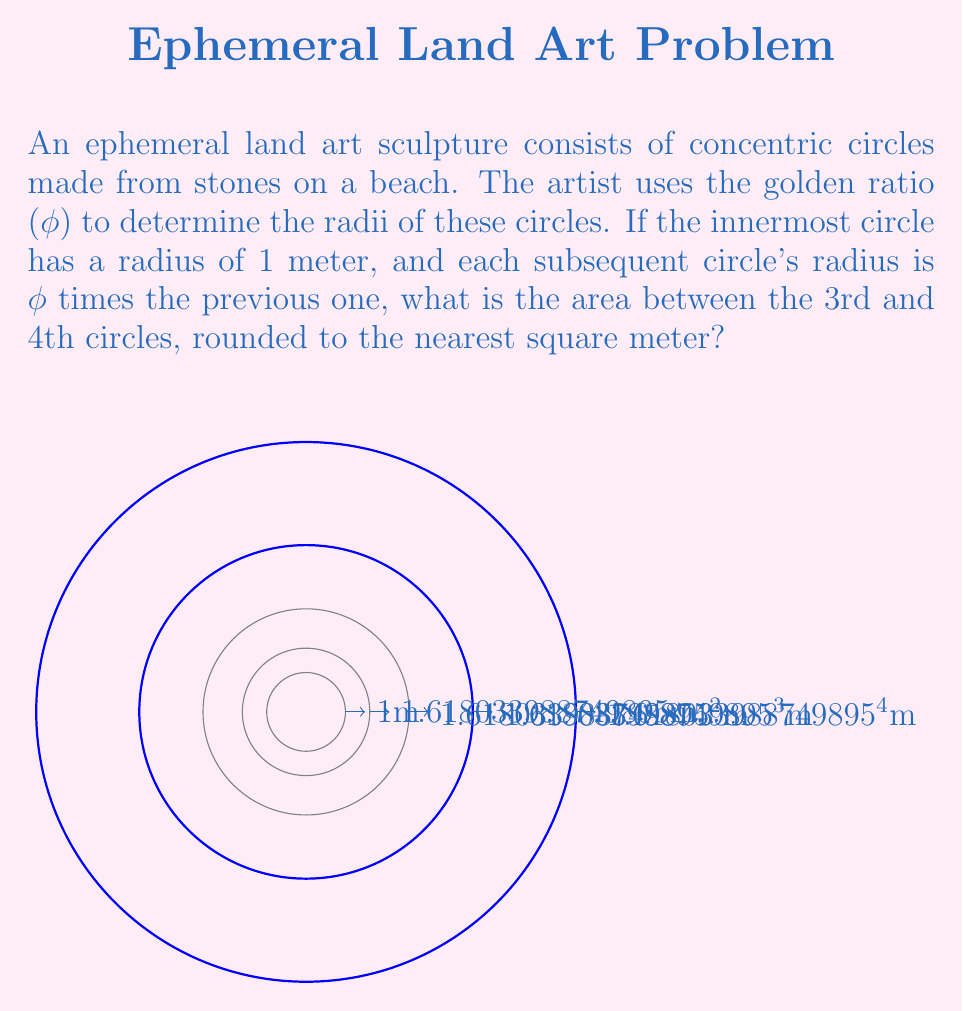Can you solve this math problem? Let's approach this step-by-step:

1) First, recall that the golden ratio φ ≈ 1.618034...

2) The radii of the circles are:
   1st circle: $r_1 = 1$ m
   2nd circle: $r_2 = φ$ m
   3rd circle: $r_3 = φ^2$ m
   4th circle: $r_4 = φ^3$ m

3) The area between the 3rd and 4th circles is the difference of their areas:
   $A = π(r_4^2 - r_3^2)$

4) Substituting the radii:
   $A = π((φ^3)^2 - (φ^2)^2)$

5) Simplify:
   $A = π(φ^6 - φ^4)$

6) Factor out φ^4:
   $A = πφ^4(φ^2 - 1)$

7) Recall the identity $φ^2 = φ + 1$:
   $A = πφ^4(φ + 1 - 1) = πφ^5$

8) Now let's calculate:
   $φ^5 ≈ 11.09017$
   $π ≈ 3.14159$
   $A ≈ 3.14159 * 11.09017 ≈ 34.8472$ m²

9) Rounding to the nearest square meter:
   $A ≈ 35$ m²
Answer: 35 m² 